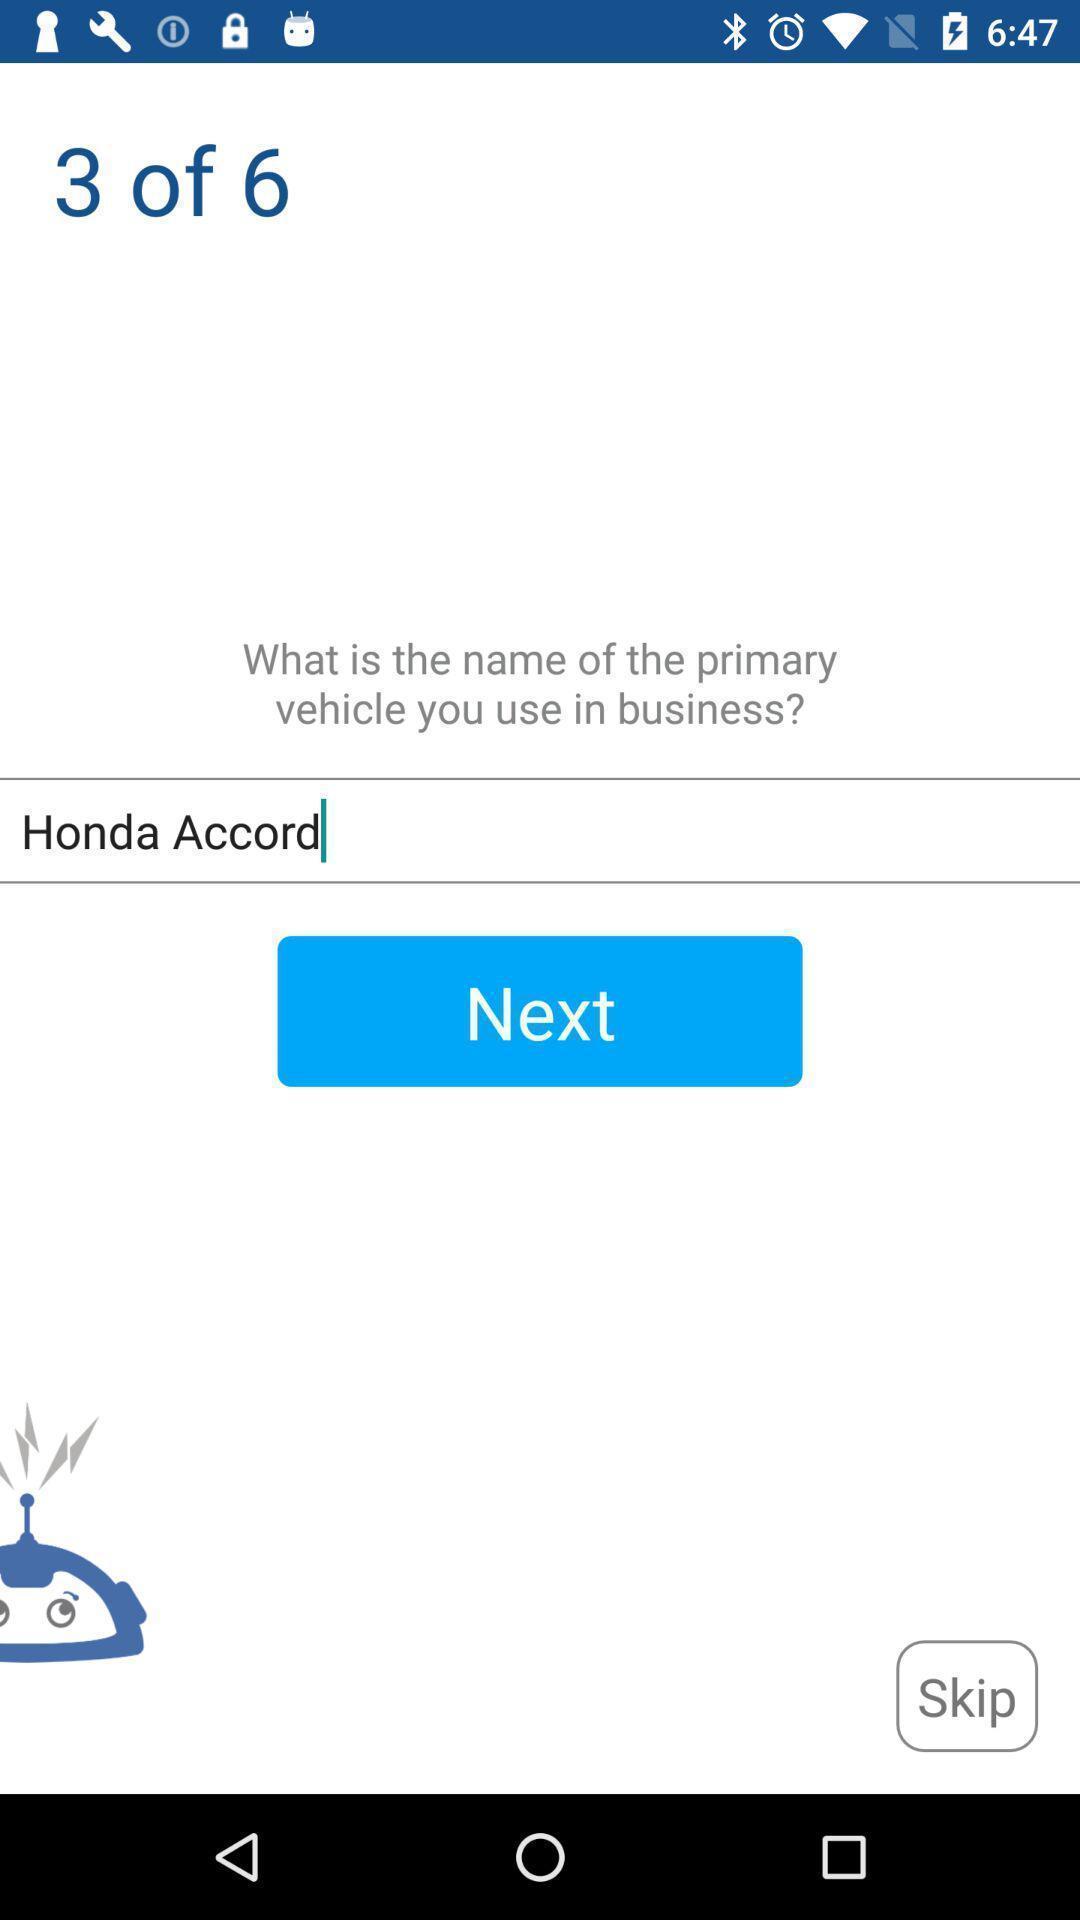Please provide a description for this image. Vehicle name page of a car app. 